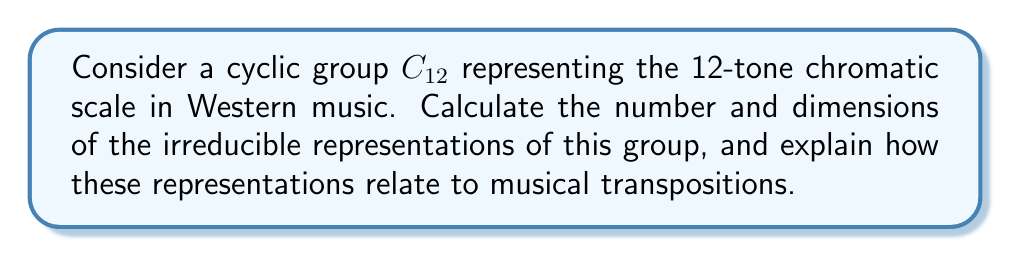Could you help me with this problem? To solve this problem, we'll follow these steps:

1) Recall that for a cyclic group $C_n$, there are exactly $n$ irreducible representations, all of dimension 1.

2) In this case, $n = 12$, so we have 12 irreducible representations.

3) These representations can be labeled as $\rho_k$ for $k = 0, 1, ..., 11$.

4) Each representation $\rho_k$ acts on a complex number $z$ as follows:
   $$\rho_k(g^j)(z) = e^{2\pi i jk/12} z$$
   where $g$ is the generator of the group and $j = 0, 1, ..., 11$.

5) Musically, these representations correspond to different transpositions:
   - $\rho_0$ is the trivial representation (no transposition)
   - $\rho_1$ represents transposition by one semitone
   - $\rho_2$ represents transposition by two semitones (a whole tone)
   - And so on...

6) The fact that all representations are 1-dimensional reflects that transposition is a simple scalar multiplication in the complex plane.

7) The cyclical nature of the group ($\rho_{12} = \rho_0$) corresponds to the octave equivalence in music.

This representation theory approach provides a mathematical framework for understanding musical transpositions and their relationships within the 12-tone system.
Answer: 12 irreducible representations, all 1-dimensional 